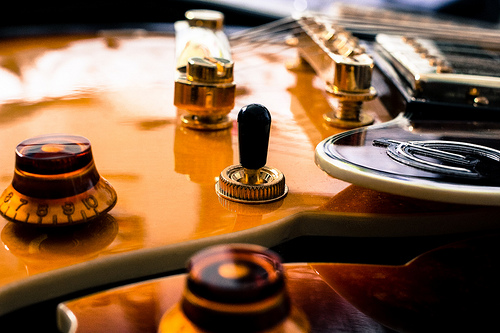<image>
Is there a brass item next to the gold object? Yes. The brass item is positioned adjacent to the gold object, located nearby in the same general area. 